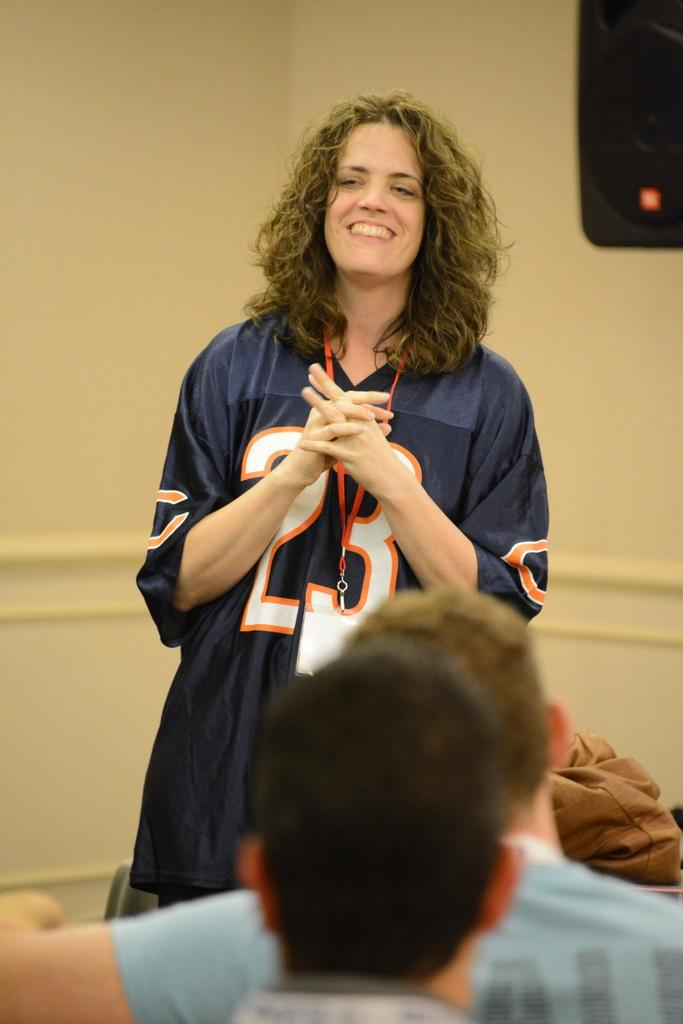Who is present in the image? There is a woman in the image. What is the woman doing in the image? The woman is smiling in the image. What object is in front of the woman? There is a bag in front of the woman. How many people are sitting in the image? There are two people sitting in the image. What is behind the woman? There is a wall behind the woman. What type of animals can be seen on the farm in the image? There is no farm or animals present in the image; it features a woman, a bag, and two people sitting. How many legs does the cave have in the image? There is no cave present in the image, so it is not possible to determine how many legs it might have. 